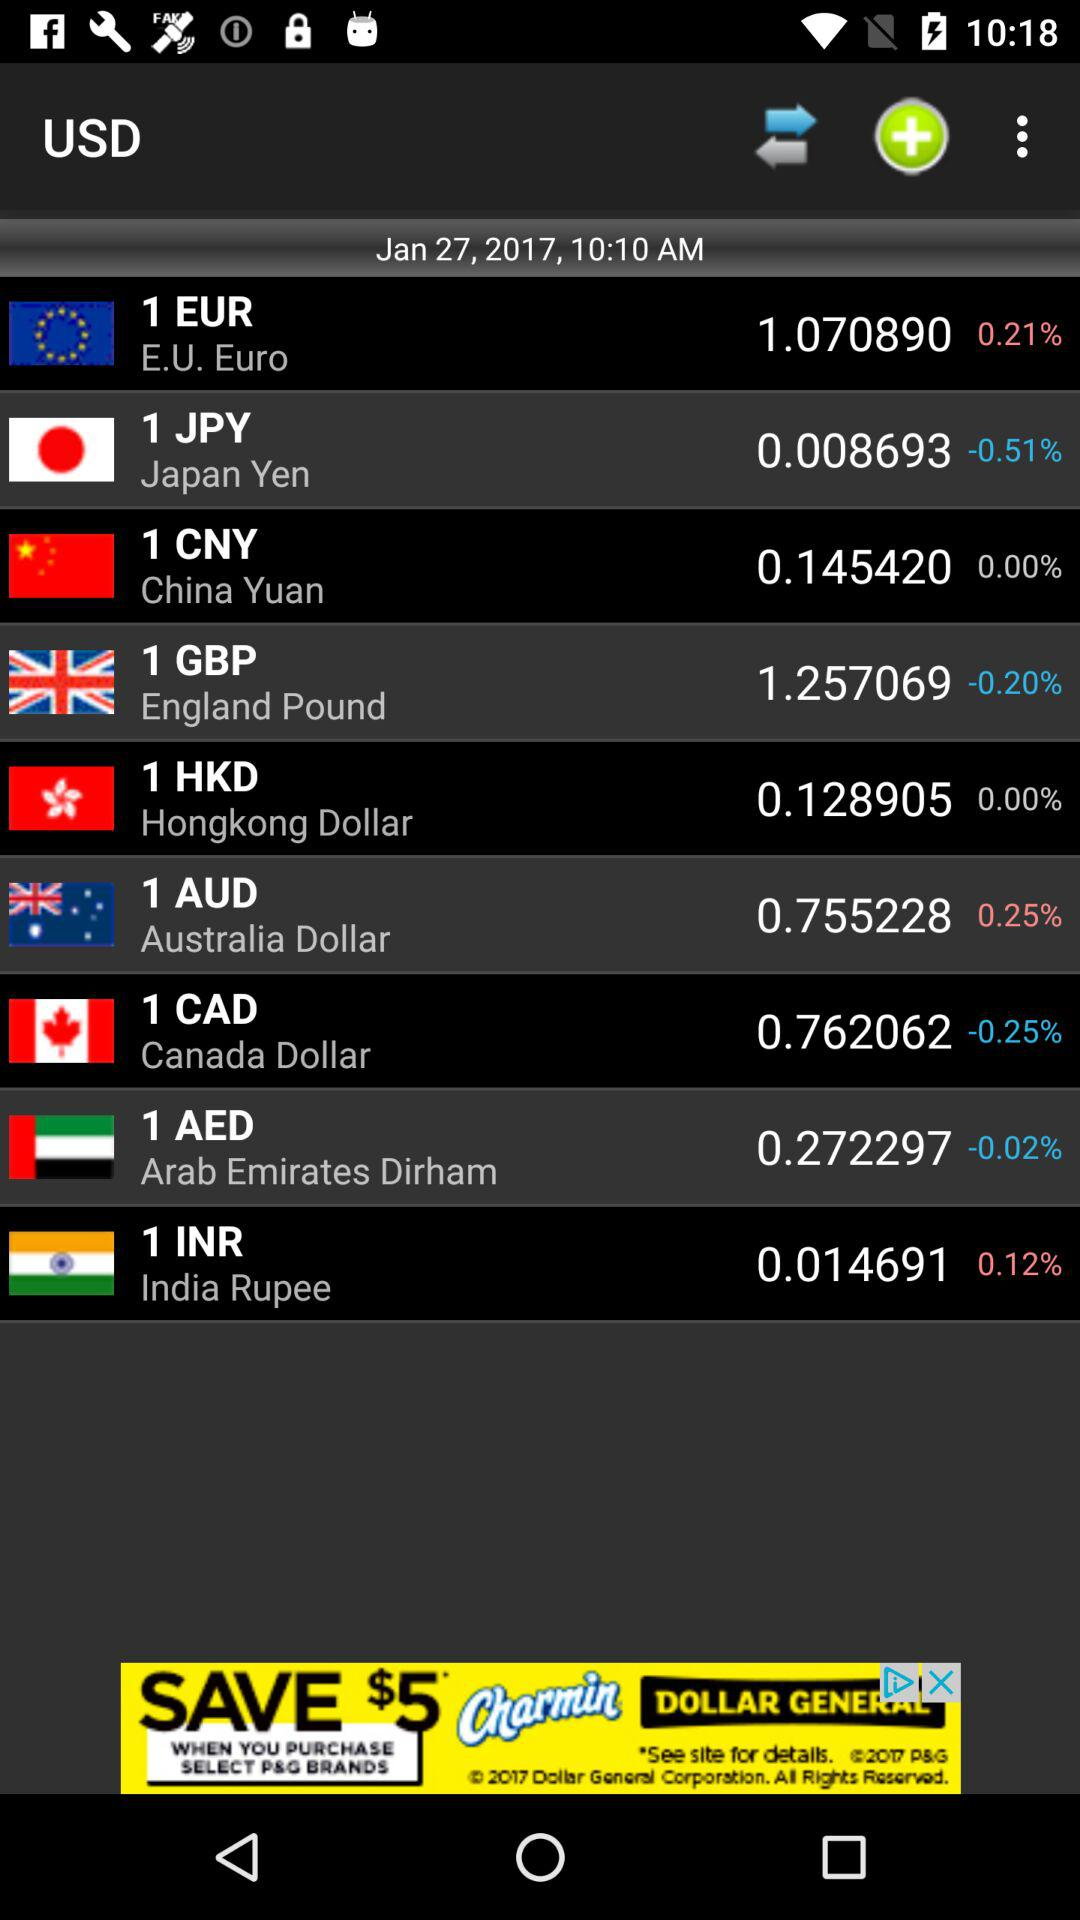What is the selected time? The selected time is 10:10 AM. 